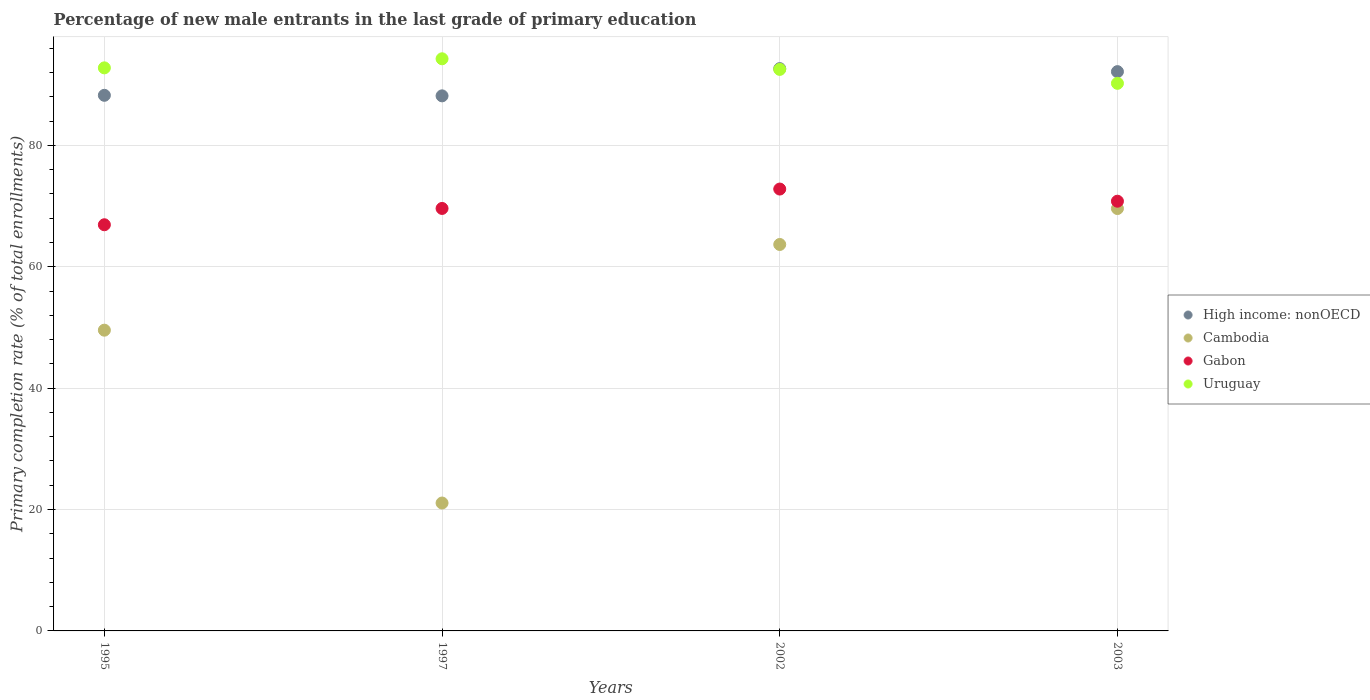How many different coloured dotlines are there?
Offer a terse response. 4. Is the number of dotlines equal to the number of legend labels?
Your answer should be very brief. Yes. What is the percentage of new male entrants in Gabon in 2002?
Make the answer very short. 72.81. Across all years, what is the maximum percentage of new male entrants in High income: nonOECD?
Make the answer very short. 92.65. Across all years, what is the minimum percentage of new male entrants in Gabon?
Provide a short and direct response. 66.93. What is the total percentage of new male entrants in High income: nonOECD in the graph?
Ensure brevity in your answer.  361.24. What is the difference between the percentage of new male entrants in Gabon in 1997 and that in 2003?
Your answer should be compact. -1.19. What is the difference between the percentage of new male entrants in High income: nonOECD in 2003 and the percentage of new male entrants in Cambodia in 1995?
Your answer should be very brief. 42.6. What is the average percentage of new male entrants in Cambodia per year?
Your answer should be very brief. 50.98. In the year 2002, what is the difference between the percentage of new male entrants in Cambodia and percentage of new male entrants in Gabon?
Provide a succinct answer. -9.13. In how many years, is the percentage of new male entrants in Gabon greater than 12 %?
Give a very brief answer. 4. What is the ratio of the percentage of new male entrants in Cambodia in 1995 to that in 1997?
Your response must be concise. 2.35. Is the percentage of new male entrants in Uruguay in 2002 less than that in 2003?
Give a very brief answer. No. What is the difference between the highest and the second highest percentage of new male entrants in Uruguay?
Offer a very short reply. 1.5. What is the difference between the highest and the lowest percentage of new male entrants in Gabon?
Your answer should be very brief. 5.88. In how many years, is the percentage of new male entrants in High income: nonOECD greater than the average percentage of new male entrants in High income: nonOECD taken over all years?
Provide a succinct answer. 2. Is the sum of the percentage of new male entrants in Gabon in 2002 and 2003 greater than the maximum percentage of new male entrants in Uruguay across all years?
Your answer should be very brief. Yes. Is it the case that in every year, the sum of the percentage of new male entrants in Cambodia and percentage of new male entrants in Uruguay  is greater than the percentage of new male entrants in High income: nonOECD?
Provide a succinct answer. Yes. Does the percentage of new male entrants in Gabon monotonically increase over the years?
Your response must be concise. No. Is the percentage of new male entrants in High income: nonOECD strictly greater than the percentage of new male entrants in Uruguay over the years?
Provide a short and direct response. No. Is the percentage of new male entrants in Cambodia strictly less than the percentage of new male entrants in Gabon over the years?
Your answer should be compact. Yes. How many dotlines are there?
Your answer should be compact. 4. How many years are there in the graph?
Make the answer very short. 4. What is the difference between two consecutive major ticks on the Y-axis?
Your response must be concise. 20. Does the graph contain grids?
Offer a very short reply. Yes. Where does the legend appear in the graph?
Ensure brevity in your answer.  Center right. How many legend labels are there?
Keep it short and to the point. 4. What is the title of the graph?
Give a very brief answer. Percentage of new male entrants in the last grade of primary education. Does "High income" appear as one of the legend labels in the graph?
Offer a terse response. No. What is the label or title of the X-axis?
Make the answer very short. Years. What is the label or title of the Y-axis?
Offer a terse response. Primary completion rate (% of total enrollments). What is the Primary completion rate (% of total enrollments) of High income: nonOECD in 1995?
Offer a very short reply. 88.26. What is the Primary completion rate (% of total enrollments) in Cambodia in 1995?
Give a very brief answer. 49.56. What is the Primary completion rate (% of total enrollments) in Gabon in 1995?
Make the answer very short. 66.93. What is the Primary completion rate (% of total enrollments) of Uruguay in 1995?
Your answer should be very brief. 92.78. What is the Primary completion rate (% of total enrollments) of High income: nonOECD in 1997?
Your answer should be compact. 88.17. What is the Primary completion rate (% of total enrollments) of Cambodia in 1997?
Provide a short and direct response. 21.08. What is the Primary completion rate (% of total enrollments) of Gabon in 1997?
Offer a terse response. 69.62. What is the Primary completion rate (% of total enrollments) in Uruguay in 1997?
Provide a short and direct response. 94.28. What is the Primary completion rate (% of total enrollments) of High income: nonOECD in 2002?
Keep it short and to the point. 92.65. What is the Primary completion rate (% of total enrollments) of Cambodia in 2002?
Provide a succinct answer. 63.68. What is the Primary completion rate (% of total enrollments) of Gabon in 2002?
Your answer should be very brief. 72.81. What is the Primary completion rate (% of total enrollments) of Uruguay in 2002?
Your response must be concise. 92.53. What is the Primary completion rate (% of total enrollments) in High income: nonOECD in 2003?
Provide a succinct answer. 92.16. What is the Primary completion rate (% of total enrollments) of Cambodia in 2003?
Offer a very short reply. 69.6. What is the Primary completion rate (% of total enrollments) in Gabon in 2003?
Keep it short and to the point. 70.81. What is the Primary completion rate (% of total enrollments) in Uruguay in 2003?
Ensure brevity in your answer.  90.23. Across all years, what is the maximum Primary completion rate (% of total enrollments) in High income: nonOECD?
Offer a very short reply. 92.65. Across all years, what is the maximum Primary completion rate (% of total enrollments) of Cambodia?
Offer a very short reply. 69.6. Across all years, what is the maximum Primary completion rate (% of total enrollments) in Gabon?
Your answer should be compact. 72.81. Across all years, what is the maximum Primary completion rate (% of total enrollments) of Uruguay?
Your response must be concise. 94.28. Across all years, what is the minimum Primary completion rate (% of total enrollments) of High income: nonOECD?
Your response must be concise. 88.17. Across all years, what is the minimum Primary completion rate (% of total enrollments) of Cambodia?
Keep it short and to the point. 21.08. Across all years, what is the minimum Primary completion rate (% of total enrollments) of Gabon?
Provide a short and direct response. 66.93. Across all years, what is the minimum Primary completion rate (% of total enrollments) of Uruguay?
Offer a terse response. 90.23. What is the total Primary completion rate (% of total enrollments) of High income: nonOECD in the graph?
Your answer should be very brief. 361.24. What is the total Primary completion rate (% of total enrollments) of Cambodia in the graph?
Offer a terse response. 203.91. What is the total Primary completion rate (% of total enrollments) in Gabon in the graph?
Offer a terse response. 280.16. What is the total Primary completion rate (% of total enrollments) in Uruguay in the graph?
Your answer should be compact. 369.81. What is the difference between the Primary completion rate (% of total enrollments) in High income: nonOECD in 1995 and that in 1997?
Ensure brevity in your answer.  0.09. What is the difference between the Primary completion rate (% of total enrollments) in Cambodia in 1995 and that in 1997?
Keep it short and to the point. 28.48. What is the difference between the Primary completion rate (% of total enrollments) of Gabon in 1995 and that in 1997?
Ensure brevity in your answer.  -2.69. What is the difference between the Primary completion rate (% of total enrollments) in Uruguay in 1995 and that in 1997?
Offer a terse response. -1.5. What is the difference between the Primary completion rate (% of total enrollments) of High income: nonOECD in 1995 and that in 2002?
Offer a terse response. -4.4. What is the difference between the Primary completion rate (% of total enrollments) of Cambodia in 1995 and that in 2002?
Your response must be concise. -14.12. What is the difference between the Primary completion rate (% of total enrollments) of Gabon in 1995 and that in 2002?
Your answer should be very brief. -5.88. What is the difference between the Primary completion rate (% of total enrollments) of Uruguay in 1995 and that in 2002?
Offer a very short reply. 0.25. What is the difference between the Primary completion rate (% of total enrollments) in High income: nonOECD in 1995 and that in 2003?
Keep it short and to the point. -3.9. What is the difference between the Primary completion rate (% of total enrollments) in Cambodia in 1995 and that in 2003?
Your answer should be compact. -20.04. What is the difference between the Primary completion rate (% of total enrollments) of Gabon in 1995 and that in 2003?
Provide a short and direct response. -3.88. What is the difference between the Primary completion rate (% of total enrollments) of Uruguay in 1995 and that in 2003?
Offer a terse response. 2.55. What is the difference between the Primary completion rate (% of total enrollments) of High income: nonOECD in 1997 and that in 2002?
Ensure brevity in your answer.  -4.49. What is the difference between the Primary completion rate (% of total enrollments) of Cambodia in 1997 and that in 2002?
Offer a very short reply. -42.6. What is the difference between the Primary completion rate (% of total enrollments) of Gabon in 1997 and that in 2002?
Your response must be concise. -3.2. What is the difference between the Primary completion rate (% of total enrollments) in Uruguay in 1997 and that in 2002?
Provide a short and direct response. 1.75. What is the difference between the Primary completion rate (% of total enrollments) in High income: nonOECD in 1997 and that in 2003?
Make the answer very short. -3.99. What is the difference between the Primary completion rate (% of total enrollments) in Cambodia in 1997 and that in 2003?
Your response must be concise. -48.52. What is the difference between the Primary completion rate (% of total enrollments) in Gabon in 1997 and that in 2003?
Keep it short and to the point. -1.19. What is the difference between the Primary completion rate (% of total enrollments) of Uruguay in 1997 and that in 2003?
Give a very brief answer. 4.04. What is the difference between the Primary completion rate (% of total enrollments) in High income: nonOECD in 2002 and that in 2003?
Your answer should be compact. 0.5. What is the difference between the Primary completion rate (% of total enrollments) of Cambodia in 2002 and that in 2003?
Give a very brief answer. -5.92. What is the difference between the Primary completion rate (% of total enrollments) in Gabon in 2002 and that in 2003?
Offer a very short reply. 2. What is the difference between the Primary completion rate (% of total enrollments) in Uruguay in 2002 and that in 2003?
Make the answer very short. 2.29. What is the difference between the Primary completion rate (% of total enrollments) of High income: nonOECD in 1995 and the Primary completion rate (% of total enrollments) of Cambodia in 1997?
Offer a terse response. 67.18. What is the difference between the Primary completion rate (% of total enrollments) in High income: nonOECD in 1995 and the Primary completion rate (% of total enrollments) in Gabon in 1997?
Offer a very short reply. 18.64. What is the difference between the Primary completion rate (% of total enrollments) in High income: nonOECD in 1995 and the Primary completion rate (% of total enrollments) in Uruguay in 1997?
Offer a terse response. -6.02. What is the difference between the Primary completion rate (% of total enrollments) in Cambodia in 1995 and the Primary completion rate (% of total enrollments) in Gabon in 1997?
Keep it short and to the point. -20.06. What is the difference between the Primary completion rate (% of total enrollments) of Cambodia in 1995 and the Primary completion rate (% of total enrollments) of Uruguay in 1997?
Your response must be concise. -44.72. What is the difference between the Primary completion rate (% of total enrollments) in Gabon in 1995 and the Primary completion rate (% of total enrollments) in Uruguay in 1997?
Provide a succinct answer. -27.35. What is the difference between the Primary completion rate (% of total enrollments) in High income: nonOECD in 1995 and the Primary completion rate (% of total enrollments) in Cambodia in 2002?
Your answer should be compact. 24.58. What is the difference between the Primary completion rate (% of total enrollments) in High income: nonOECD in 1995 and the Primary completion rate (% of total enrollments) in Gabon in 2002?
Offer a terse response. 15.45. What is the difference between the Primary completion rate (% of total enrollments) of High income: nonOECD in 1995 and the Primary completion rate (% of total enrollments) of Uruguay in 2002?
Provide a succinct answer. -4.27. What is the difference between the Primary completion rate (% of total enrollments) in Cambodia in 1995 and the Primary completion rate (% of total enrollments) in Gabon in 2002?
Provide a succinct answer. -23.25. What is the difference between the Primary completion rate (% of total enrollments) of Cambodia in 1995 and the Primary completion rate (% of total enrollments) of Uruguay in 2002?
Ensure brevity in your answer.  -42.97. What is the difference between the Primary completion rate (% of total enrollments) in Gabon in 1995 and the Primary completion rate (% of total enrollments) in Uruguay in 2002?
Ensure brevity in your answer.  -25.6. What is the difference between the Primary completion rate (% of total enrollments) of High income: nonOECD in 1995 and the Primary completion rate (% of total enrollments) of Cambodia in 2003?
Offer a very short reply. 18.66. What is the difference between the Primary completion rate (% of total enrollments) in High income: nonOECD in 1995 and the Primary completion rate (% of total enrollments) in Gabon in 2003?
Give a very brief answer. 17.45. What is the difference between the Primary completion rate (% of total enrollments) of High income: nonOECD in 1995 and the Primary completion rate (% of total enrollments) of Uruguay in 2003?
Give a very brief answer. -1.97. What is the difference between the Primary completion rate (% of total enrollments) of Cambodia in 1995 and the Primary completion rate (% of total enrollments) of Gabon in 2003?
Give a very brief answer. -21.25. What is the difference between the Primary completion rate (% of total enrollments) of Cambodia in 1995 and the Primary completion rate (% of total enrollments) of Uruguay in 2003?
Your answer should be very brief. -40.67. What is the difference between the Primary completion rate (% of total enrollments) of Gabon in 1995 and the Primary completion rate (% of total enrollments) of Uruguay in 2003?
Make the answer very short. -23.3. What is the difference between the Primary completion rate (% of total enrollments) in High income: nonOECD in 1997 and the Primary completion rate (% of total enrollments) in Cambodia in 2002?
Keep it short and to the point. 24.49. What is the difference between the Primary completion rate (% of total enrollments) of High income: nonOECD in 1997 and the Primary completion rate (% of total enrollments) of Gabon in 2002?
Your response must be concise. 15.36. What is the difference between the Primary completion rate (% of total enrollments) of High income: nonOECD in 1997 and the Primary completion rate (% of total enrollments) of Uruguay in 2002?
Provide a short and direct response. -4.36. What is the difference between the Primary completion rate (% of total enrollments) of Cambodia in 1997 and the Primary completion rate (% of total enrollments) of Gabon in 2002?
Your answer should be very brief. -51.73. What is the difference between the Primary completion rate (% of total enrollments) of Cambodia in 1997 and the Primary completion rate (% of total enrollments) of Uruguay in 2002?
Provide a succinct answer. -71.45. What is the difference between the Primary completion rate (% of total enrollments) in Gabon in 1997 and the Primary completion rate (% of total enrollments) in Uruguay in 2002?
Your response must be concise. -22.91. What is the difference between the Primary completion rate (% of total enrollments) of High income: nonOECD in 1997 and the Primary completion rate (% of total enrollments) of Cambodia in 2003?
Your response must be concise. 18.57. What is the difference between the Primary completion rate (% of total enrollments) in High income: nonOECD in 1997 and the Primary completion rate (% of total enrollments) in Gabon in 2003?
Your answer should be very brief. 17.36. What is the difference between the Primary completion rate (% of total enrollments) of High income: nonOECD in 1997 and the Primary completion rate (% of total enrollments) of Uruguay in 2003?
Your answer should be very brief. -2.06. What is the difference between the Primary completion rate (% of total enrollments) of Cambodia in 1997 and the Primary completion rate (% of total enrollments) of Gabon in 2003?
Offer a terse response. -49.73. What is the difference between the Primary completion rate (% of total enrollments) of Cambodia in 1997 and the Primary completion rate (% of total enrollments) of Uruguay in 2003?
Ensure brevity in your answer.  -69.15. What is the difference between the Primary completion rate (% of total enrollments) in Gabon in 1997 and the Primary completion rate (% of total enrollments) in Uruguay in 2003?
Offer a terse response. -20.62. What is the difference between the Primary completion rate (% of total enrollments) in High income: nonOECD in 2002 and the Primary completion rate (% of total enrollments) in Cambodia in 2003?
Keep it short and to the point. 23.06. What is the difference between the Primary completion rate (% of total enrollments) of High income: nonOECD in 2002 and the Primary completion rate (% of total enrollments) of Gabon in 2003?
Provide a short and direct response. 21.85. What is the difference between the Primary completion rate (% of total enrollments) of High income: nonOECD in 2002 and the Primary completion rate (% of total enrollments) of Uruguay in 2003?
Ensure brevity in your answer.  2.42. What is the difference between the Primary completion rate (% of total enrollments) in Cambodia in 2002 and the Primary completion rate (% of total enrollments) in Gabon in 2003?
Your answer should be compact. -7.13. What is the difference between the Primary completion rate (% of total enrollments) in Cambodia in 2002 and the Primary completion rate (% of total enrollments) in Uruguay in 2003?
Provide a short and direct response. -26.55. What is the difference between the Primary completion rate (% of total enrollments) in Gabon in 2002 and the Primary completion rate (% of total enrollments) in Uruguay in 2003?
Your response must be concise. -17.42. What is the average Primary completion rate (% of total enrollments) of High income: nonOECD per year?
Provide a succinct answer. 90.31. What is the average Primary completion rate (% of total enrollments) in Cambodia per year?
Make the answer very short. 50.98. What is the average Primary completion rate (% of total enrollments) in Gabon per year?
Your answer should be very brief. 70.04. What is the average Primary completion rate (% of total enrollments) in Uruguay per year?
Provide a short and direct response. 92.45. In the year 1995, what is the difference between the Primary completion rate (% of total enrollments) in High income: nonOECD and Primary completion rate (% of total enrollments) in Cambodia?
Provide a short and direct response. 38.7. In the year 1995, what is the difference between the Primary completion rate (% of total enrollments) in High income: nonOECD and Primary completion rate (% of total enrollments) in Gabon?
Keep it short and to the point. 21.33. In the year 1995, what is the difference between the Primary completion rate (% of total enrollments) in High income: nonOECD and Primary completion rate (% of total enrollments) in Uruguay?
Make the answer very short. -4.52. In the year 1995, what is the difference between the Primary completion rate (% of total enrollments) of Cambodia and Primary completion rate (% of total enrollments) of Gabon?
Make the answer very short. -17.37. In the year 1995, what is the difference between the Primary completion rate (% of total enrollments) of Cambodia and Primary completion rate (% of total enrollments) of Uruguay?
Your answer should be very brief. -43.22. In the year 1995, what is the difference between the Primary completion rate (% of total enrollments) of Gabon and Primary completion rate (% of total enrollments) of Uruguay?
Make the answer very short. -25.85. In the year 1997, what is the difference between the Primary completion rate (% of total enrollments) in High income: nonOECD and Primary completion rate (% of total enrollments) in Cambodia?
Offer a very short reply. 67.09. In the year 1997, what is the difference between the Primary completion rate (% of total enrollments) in High income: nonOECD and Primary completion rate (% of total enrollments) in Gabon?
Your response must be concise. 18.55. In the year 1997, what is the difference between the Primary completion rate (% of total enrollments) of High income: nonOECD and Primary completion rate (% of total enrollments) of Uruguay?
Give a very brief answer. -6.11. In the year 1997, what is the difference between the Primary completion rate (% of total enrollments) of Cambodia and Primary completion rate (% of total enrollments) of Gabon?
Provide a short and direct response. -48.54. In the year 1997, what is the difference between the Primary completion rate (% of total enrollments) of Cambodia and Primary completion rate (% of total enrollments) of Uruguay?
Your answer should be very brief. -73.2. In the year 1997, what is the difference between the Primary completion rate (% of total enrollments) of Gabon and Primary completion rate (% of total enrollments) of Uruguay?
Give a very brief answer. -24.66. In the year 2002, what is the difference between the Primary completion rate (% of total enrollments) in High income: nonOECD and Primary completion rate (% of total enrollments) in Cambodia?
Offer a terse response. 28.98. In the year 2002, what is the difference between the Primary completion rate (% of total enrollments) in High income: nonOECD and Primary completion rate (% of total enrollments) in Gabon?
Your response must be concise. 19.84. In the year 2002, what is the difference between the Primary completion rate (% of total enrollments) in High income: nonOECD and Primary completion rate (% of total enrollments) in Uruguay?
Your answer should be very brief. 0.13. In the year 2002, what is the difference between the Primary completion rate (% of total enrollments) of Cambodia and Primary completion rate (% of total enrollments) of Gabon?
Your answer should be very brief. -9.13. In the year 2002, what is the difference between the Primary completion rate (% of total enrollments) in Cambodia and Primary completion rate (% of total enrollments) in Uruguay?
Provide a short and direct response. -28.85. In the year 2002, what is the difference between the Primary completion rate (% of total enrollments) in Gabon and Primary completion rate (% of total enrollments) in Uruguay?
Your response must be concise. -19.72. In the year 2003, what is the difference between the Primary completion rate (% of total enrollments) of High income: nonOECD and Primary completion rate (% of total enrollments) of Cambodia?
Ensure brevity in your answer.  22.56. In the year 2003, what is the difference between the Primary completion rate (% of total enrollments) of High income: nonOECD and Primary completion rate (% of total enrollments) of Gabon?
Make the answer very short. 21.35. In the year 2003, what is the difference between the Primary completion rate (% of total enrollments) of High income: nonOECD and Primary completion rate (% of total enrollments) of Uruguay?
Provide a succinct answer. 1.93. In the year 2003, what is the difference between the Primary completion rate (% of total enrollments) in Cambodia and Primary completion rate (% of total enrollments) in Gabon?
Provide a succinct answer. -1.21. In the year 2003, what is the difference between the Primary completion rate (% of total enrollments) of Cambodia and Primary completion rate (% of total enrollments) of Uruguay?
Your response must be concise. -20.63. In the year 2003, what is the difference between the Primary completion rate (% of total enrollments) of Gabon and Primary completion rate (% of total enrollments) of Uruguay?
Keep it short and to the point. -19.42. What is the ratio of the Primary completion rate (% of total enrollments) of High income: nonOECD in 1995 to that in 1997?
Your response must be concise. 1. What is the ratio of the Primary completion rate (% of total enrollments) in Cambodia in 1995 to that in 1997?
Your answer should be compact. 2.35. What is the ratio of the Primary completion rate (% of total enrollments) of Gabon in 1995 to that in 1997?
Offer a very short reply. 0.96. What is the ratio of the Primary completion rate (% of total enrollments) of Uruguay in 1995 to that in 1997?
Give a very brief answer. 0.98. What is the ratio of the Primary completion rate (% of total enrollments) in High income: nonOECD in 1995 to that in 2002?
Provide a short and direct response. 0.95. What is the ratio of the Primary completion rate (% of total enrollments) in Cambodia in 1995 to that in 2002?
Offer a very short reply. 0.78. What is the ratio of the Primary completion rate (% of total enrollments) in Gabon in 1995 to that in 2002?
Provide a succinct answer. 0.92. What is the ratio of the Primary completion rate (% of total enrollments) in High income: nonOECD in 1995 to that in 2003?
Keep it short and to the point. 0.96. What is the ratio of the Primary completion rate (% of total enrollments) in Cambodia in 1995 to that in 2003?
Your answer should be very brief. 0.71. What is the ratio of the Primary completion rate (% of total enrollments) in Gabon in 1995 to that in 2003?
Offer a very short reply. 0.95. What is the ratio of the Primary completion rate (% of total enrollments) of Uruguay in 1995 to that in 2003?
Keep it short and to the point. 1.03. What is the ratio of the Primary completion rate (% of total enrollments) in High income: nonOECD in 1997 to that in 2002?
Keep it short and to the point. 0.95. What is the ratio of the Primary completion rate (% of total enrollments) of Cambodia in 1997 to that in 2002?
Your answer should be compact. 0.33. What is the ratio of the Primary completion rate (% of total enrollments) in Gabon in 1997 to that in 2002?
Provide a short and direct response. 0.96. What is the ratio of the Primary completion rate (% of total enrollments) in Uruguay in 1997 to that in 2002?
Your answer should be compact. 1.02. What is the ratio of the Primary completion rate (% of total enrollments) of High income: nonOECD in 1997 to that in 2003?
Offer a very short reply. 0.96. What is the ratio of the Primary completion rate (% of total enrollments) in Cambodia in 1997 to that in 2003?
Keep it short and to the point. 0.3. What is the ratio of the Primary completion rate (% of total enrollments) in Gabon in 1997 to that in 2003?
Your response must be concise. 0.98. What is the ratio of the Primary completion rate (% of total enrollments) in Uruguay in 1997 to that in 2003?
Make the answer very short. 1.04. What is the ratio of the Primary completion rate (% of total enrollments) in High income: nonOECD in 2002 to that in 2003?
Keep it short and to the point. 1.01. What is the ratio of the Primary completion rate (% of total enrollments) in Cambodia in 2002 to that in 2003?
Ensure brevity in your answer.  0.91. What is the ratio of the Primary completion rate (% of total enrollments) of Gabon in 2002 to that in 2003?
Provide a short and direct response. 1.03. What is the ratio of the Primary completion rate (% of total enrollments) of Uruguay in 2002 to that in 2003?
Offer a very short reply. 1.03. What is the difference between the highest and the second highest Primary completion rate (% of total enrollments) in High income: nonOECD?
Ensure brevity in your answer.  0.5. What is the difference between the highest and the second highest Primary completion rate (% of total enrollments) in Cambodia?
Your response must be concise. 5.92. What is the difference between the highest and the second highest Primary completion rate (% of total enrollments) of Gabon?
Provide a short and direct response. 2. What is the difference between the highest and the second highest Primary completion rate (% of total enrollments) in Uruguay?
Your response must be concise. 1.5. What is the difference between the highest and the lowest Primary completion rate (% of total enrollments) of High income: nonOECD?
Provide a succinct answer. 4.49. What is the difference between the highest and the lowest Primary completion rate (% of total enrollments) of Cambodia?
Offer a terse response. 48.52. What is the difference between the highest and the lowest Primary completion rate (% of total enrollments) in Gabon?
Keep it short and to the point. 5.88. What is the difference between the highest and the lowest Primary completion rate (% of total enrollments) in Uruguay?
Give a very brief answer. 4.04. 